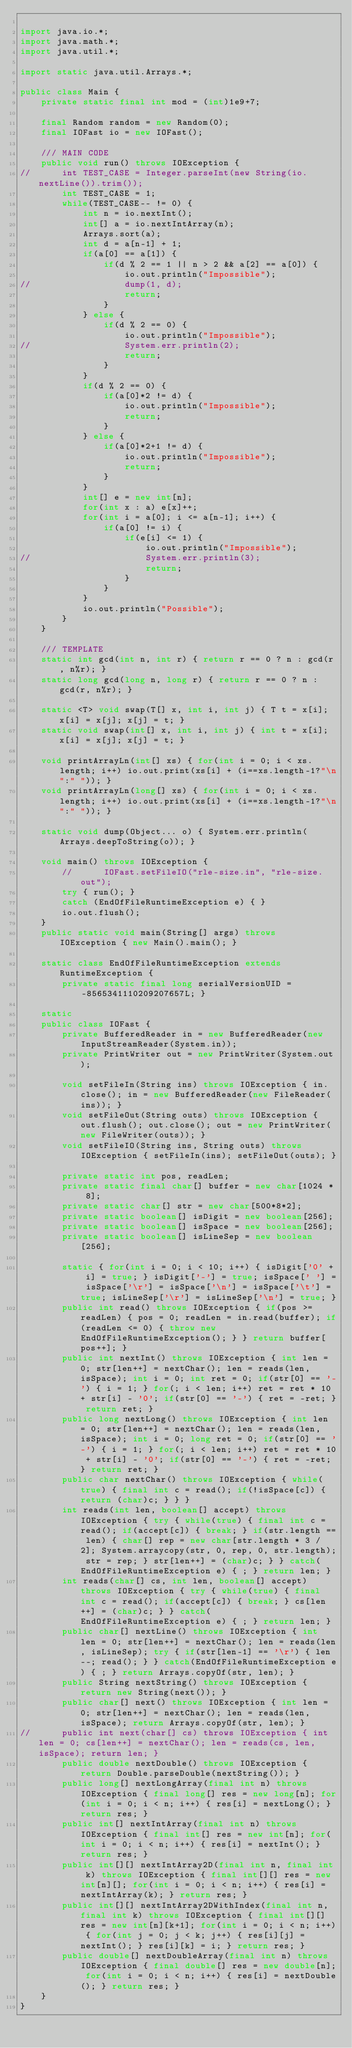<code> <loc_0><loc_0><loc_500><loc_500><_Java_>
import java.io.*;
import java.math.*;
import java.util.*;

import static java.util.Arrays.*;

public class Main {
	private static final int mod = (int)1e9+7;

	final Random random = new Random(0);
	final IOFast io = new IOFast();

	/// MAIN CODE
	public void run() throws IOException {
//		int TEST_CASE = Integer.parseInt(new String(io.nextLine()).trim());
		int TEST_CASE = 1;
		while(TEST_CASE-- != 0) {
			int n = io.nextInt();
			int[] a = io.nextIntArray(n);
			Arrays.sort(a);
			int d = a[n-1] + 1;
			if(a[0] == a[1]) {
				if(d % 2 == 1 || n > 2 && a[2] == a[0]) {
					io.out.println("Impossible");
//					dump(1, d);
					return;
				}
			} else {
				if(d % 2 == 0) {
					io.out.println("Impossible");
//					System.err.println(2);
					return;
				}
			}
			if(d % 2 == 0) {
				if(a[0]*2 != d) {
					io.out.println("Impossible");
					return;
				}
			} else {
				if(a[0]*2+1 != d) {
					io.out.println("Impossible");
					return;
				}
			}
			int[] e = new int[n];
			for(int x : a) e[x]++;
			for(int i = a[0]; i <= a[n-1]; i++) {
				if(a[0] != i) {
					if(e[i] <= 1) {
						io.out.println("Impossible");
//						System.err.println(3);
						return;
					}
				}
			}
			io.out.println("Possible");
		}
	}
	
	/// TEMPLATE
	static int gcd(int n, int r) { return r == 0 ? n : gcd(r, n%r); }
	static long gcd(long n, long r) { return r == 0 ? n : gcd(r, n%r); }
	
	static <T> void swap(T[] x, int i, int j) { T t = x[i]; x[i] = x[j]; x[j] = t; }
	static void swap(int[] x, int i, int j) { int t = x[i]; x[i] = x[j]; x[j] = t; }

	void printArrayLn(int[] xs) { for(int i = 0; i < xs.length; i++) io.out.print(xs[i] + (i==xs.length-1?"\n":" ")); }
	void printArrayLn(long[] xs) { for(int i = 0; i < xs.length; i++) io.out.print(xs[i] + (i==xs.length-1?"\n":" ")); }
	
	static void dump(Object... o) { System.err.println(Arrays.deepToString(o)); } 
	
	void main() throws IOException {
		//		IOFast.setFileIO("rle-size.in", "rle-size.out");
		try { run(); }
		catch (EndOfFileRuntimeException e) { }
		io.out.flush();
	}
	public static void main(String[] args) throws IOException { new Main().main(); }
	
	static class EndOfFileRuntimeException extends RuntimeException {
		private static final long serialVersionUID = -8565341110209207657L; }

	static
	public class IOFast {
		private BufferedReader in = new BufferedReader(new InputStreamReader(System.in));
		private PrintWriter out = new PrintWriter(System.out);

		void setFileIn(String ins) throws IOException { in.close(); in = new BufferedReader(new FileReader(ins)); }
		void setFileOut(String outs) throws IOException { out.flush(); out.close(); out = new PrintWriter(new FileWriter(outs)); }
		void setFileIO(String ins, String outs) throws IOException { setFileIn(ins); setFileOut(outs); }

		private static int pos, readLen;
		private static final char[] buffer = new char[1024 * 8];
		private static char[] str = new char[500*8*2];
		private static boolean[] isDigit = new boolean[256];
		private static boolean[] isSpace = new boolean[256];
		private static boolean[] isLineSep = new boolean[256];

		static { for(int i = 0; i < 10; i++) { isDigit['0' + i] = true; } isDigit['-'] = true; isSpace[' '] = isSpace['\r'] = isSpace['\n'] = isSpace['\t'] = true; isLineSep['\r'] = isLineSep['\n'] = true; }
		public int read() throws IOException { if(pos >= readLen) { pos = 0; readLen = in.read(buffer); if(readLen <= 0) { throw new EndOfFileRuntimeException(); } } return buffer[pos++]; }
		public int nextInt() throws IOException { int len = 0; str[len++] = nextChar(); len = reads(len, isSpace); int i = 0; int ret = 0; if(str[0] == '-') { i = 1; } for(; i < len; i++) ret = ret * 10 + str[i] - '0'; if(str[0] == '-') { ret = -ret; } return ret; }
		public long nextLong() throws IOException { int len = 0; str[len++] = nextChar(); len = reads(len, isSpace); int i = 0; long ret = 0; if(str[0] == '-') { i = 1; } for(; i < len; i++) ret = ret * 10 + str[i] - '0'; if(str[0] == '-') { ret = -ret; } return ret; }
		public char nextChar() throws IOException { while(true) { final int c = read(); if(!isSpace[c]) { return (char)c; } } }
		int reads(int len, boolean[] accept) throws IOException { try { while(true) { final int c = read(); if(accept[c]) { break; } if(str.length == len) { char[] rep = new char[str.length * 3 / 2]; System.arraycopy(str, 0, rep, 0, str.length); str = rep; } str[len++] = (char)c; } } catch(EndOfFileRuntimeException e) { ; } return len; }
		int reads(char[] cs, int len, boolean[] accept) throws IOException { try { while(true) { final int c = read(); if(accept[c]) { break; } cs[len++] = (char)c; } } catch(EndOfFileRuntimeException e) { ; } return len; }
		public char[] nextLine() throws IOException { int len = 0; str[len++] = nextChar(); len = reads(len, isLineSep); try { if(str[len-1] == '\r') { len--; read(); } } catch(EndOfFileRuntimeException e) { ; } return Arrays.copyOf(str, len); }
		public String nextString() throws IOException { return new String(next()); }
		public char[] next() throws IOException { int len = 0; str[len++] = nextChar(); len = reads(len, isSpace); return Arrays.copyOf(str, len); }
//		public int next(char[] cs) throws IOException { int len = 0; cs[len++] = nextChar(); len = reads(cs, len, isSpace); return len; }
		public double nextDouble() throws IOException { return Double.parseDouble(nextString()); }
		public long[] nextLongArray(final int n) throws IOException { final long[] res = new long[n]; for(int i = 0; i < n; i++) { res[i] = nextLong(); } return res; }
		public int[] nextIntArray(final int n) throws IOException { final int[] res = new int[n]; for(int i = 0; i < n; i++) { res[i] = nextInt(); } return res; }
		public int[][] nextIntArray2D(final int n, final int k) throws IOException { final int[][] res = new int[n][]; for(int i = 0; i < n; i++) { res[i] = nextIntArray(k); } return res; }
		public int[][] nextIntArray2DWithIndex(final int n, final int k) throws IOException { final int[][] res = new int[n][k+1]; for(int i = 0; i < n; i++) { for(int j = 0; j < k; j++) { res[i][j] = nextInt(); } res[i][k] = i; } return res; }
		public double[] nextDoubleArray(final int n) throws IOException { final double[] res = new double[n]; for(int i = 0; i < n; i++) { res[i] = nextDouble(); } return res; }
	}
}
</code> 